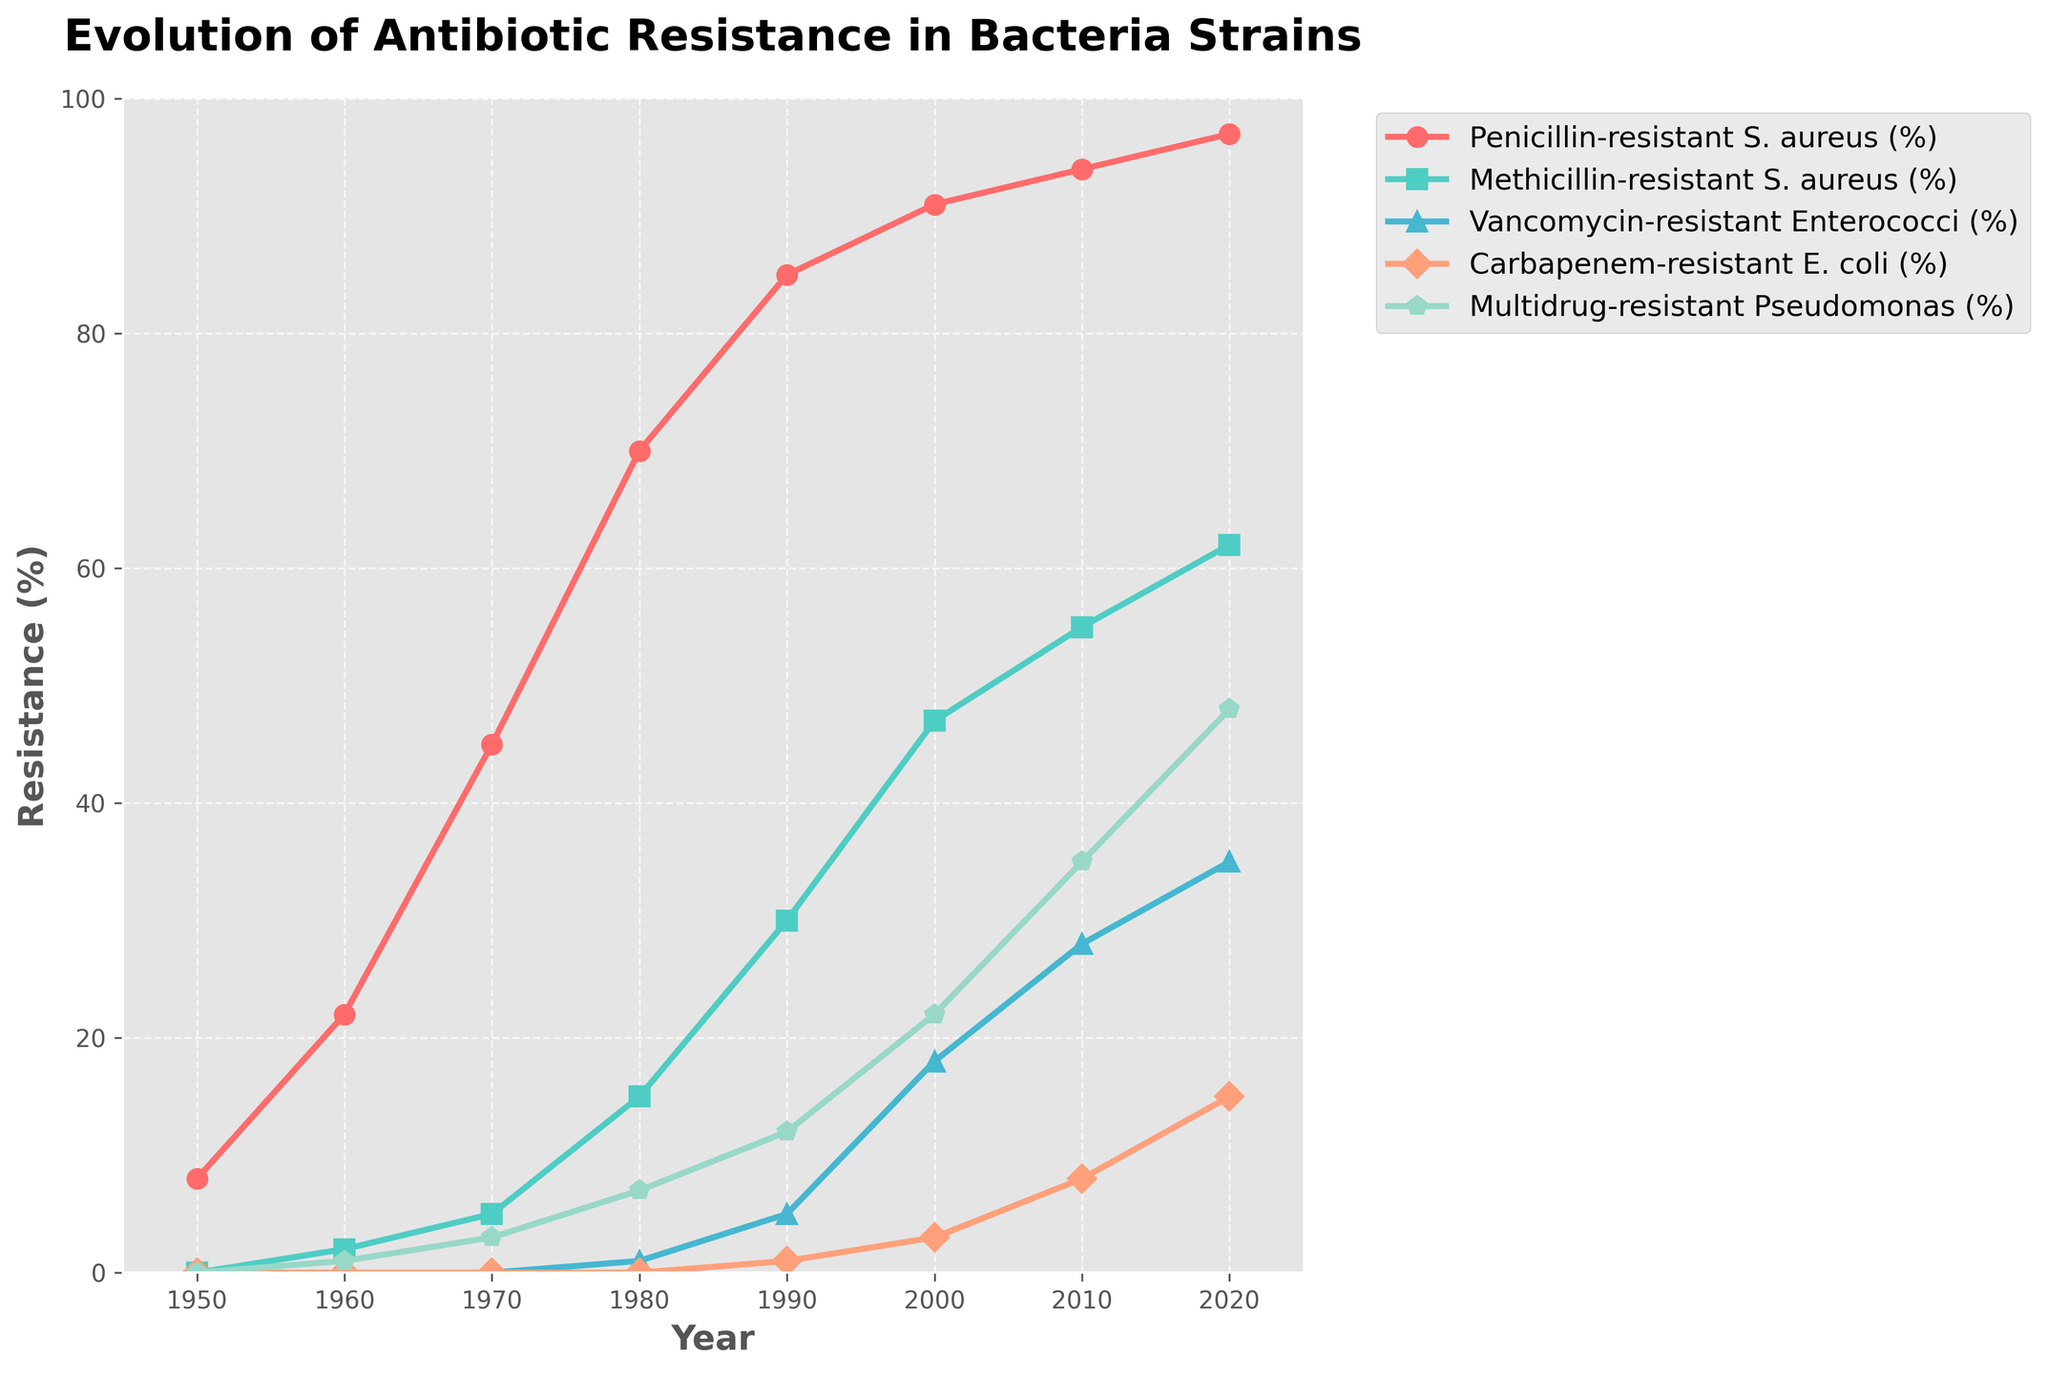What was the percentage increase in Penicillin-resistant S. aureus from 1950 to 2020? To find the percentage increase, subtract the 1950 value from the 2020 value and then divide by the 1950 value. Multiply by 100 for the percentage. (97 - 8) / 8 * 100 = 1112.5%
Answer: 1112.5% Which type of antibiotic resistance had the highest percentage in 2010? Look for the highest value in the 2010 column. Penicillin-resistant S. aureus has the highest percentage at 94%.
Answer: Penicillin-resistant S. aureus Was there any year when Vancomycin-resistant Enterococci had a higher percentage than Methicillin-resistant S. aureus? Compare the percentage of Vancomycin-resistant Enterococci and Methicillin-resistant S. aureus for each year. None of the years show that Vancomycin-resistant Enterococci's percentage is higher.
Answer: No What is the average percentage of Carbapenem-resistant E. coli from 1980 to 2020? Add the percentages from 1980, 1990, 2000, 2010, and 2020, then divide by the number of years: (0 + 1 + 3 + 8 + 15) / 5 = 5.4
Answer: 5.4 How did Multidrug-resistant Pseudomonas change from 1960 to 2000 compared to Methicillin-resistant S. aureus? Calculate the increase for both: Multidrug-resistant Pseudomonas (22 - 1) = 21, Methicillin-resistant S. aureus (47 - 2) = 45. Methicillin-resistant S. aureus increased more.
Answer: Methicillin-resistant S. aureus increased more Are Methicillin-resistant S. aureus and Carbapenem-resistant E. coli ever equal in percentage within the years shown? Compare the percentages for each year and see if they match. They are never equal in the provided years.
Answer: No What visual marker represents the Penicillin-resistant S. aureus on the graph? Identify the marker and color used for Penicillin-resistant S. aureus, which is represented by a red circle.
Answer: Red circle 